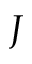<formula> <loc_0><loc_0><loc_500><loc_500>J</formula> 